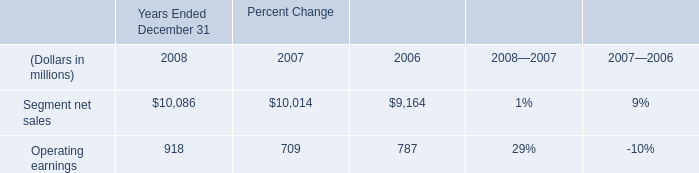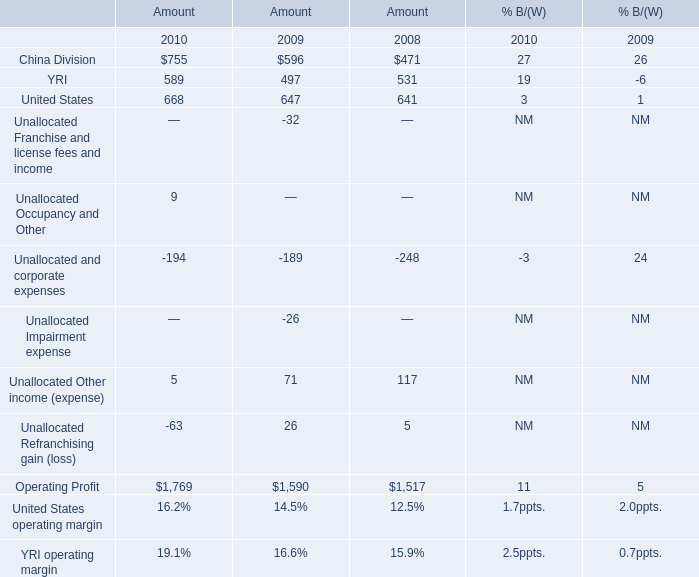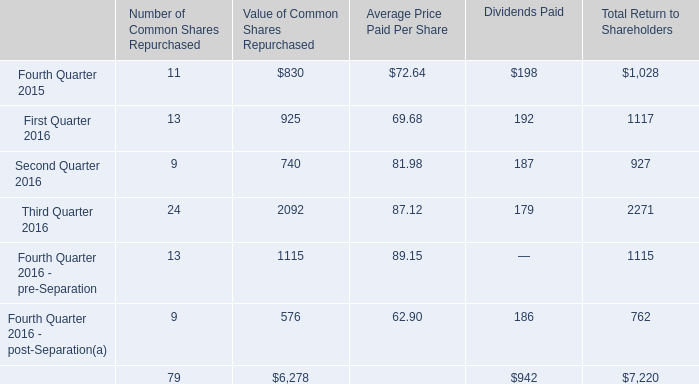What is the total amount of Third Quarter 2016 of Value of Common Shares Repurchased, Operating Profit of Amount 2008, and total of Value of Common Shares Repurchased ? 
Computations: ((2092.0 + 1517.0) + 6278.0)
Answer: 9887.0. 